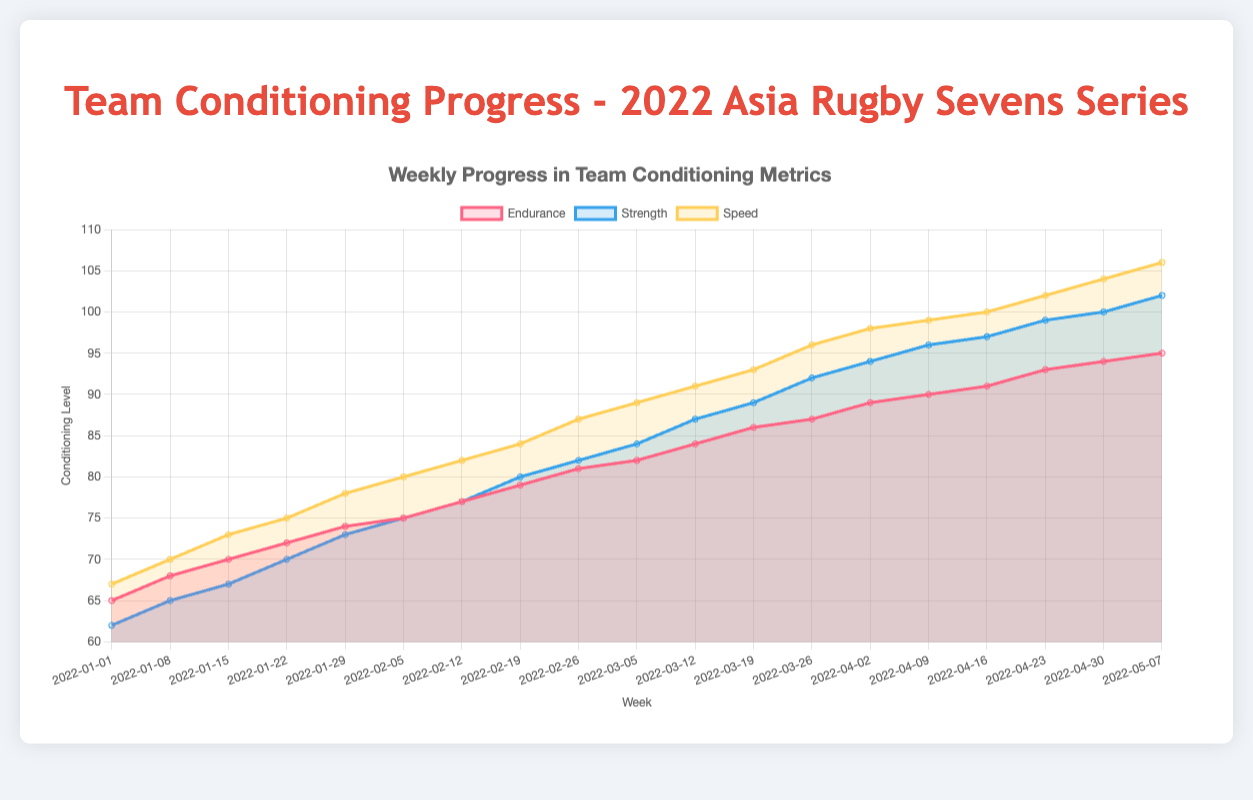What is the title of the chart? The title of the chart is usually displayed at the top and clearly indicates the purpose of the chart. In this case, at the top of the chart, it reads "Weekly Progress in Team Conditioning Metrics."
Answer: Weekly Progress in Team Conditioning Metrics What is the conditioning level of the team's endurance on the week of 2022-02-05? Find the data point corresponding to the week of 2022-02-05 on the x-axis, then look at the value indicated for endurance on the y-axis. The chart will show a filled area reaching the value.
Answer: 75 How many different metrics are visualized in this chart? Count the distinct datasets represented in the area chart, each with a different color and label. From the legend, we see three datasets: Endurance, Strength, and Speed.
Answer: 3 Which metric showed the highest level in the final week (2022-05-07)? Look at the data point for the final week (2022-05-07) and compare the values for endurance, strength, and speed. The highest value among them is the metric that showed the highest level.
Answer: Speed How did the strength metric progress from 2022-01-01 to 2022-05-07? Starting at 62 on 2022-01-01, strength steadily increases every week, reaching 102 on 2022-05-07.
Answer: It increased steadily from 62 to 102 Which metric increased the most from the first to the last recorded week? Starting values and ending values for each metric: Endurance (65 to 95), Strength (62 to 102), Speed (67 to 106). Calculate the difference for each: Endurance (95 - 65 = 30), Strength (102 - 62 = 40), Speed (106 - 67 = 39).
Answer: Strength What is the average speed metric over the first four weeks of 2022? Look at the speed values for the first four weeks: 67, 70, 73, 75. Sum these values (67 + 70 + 73 + 75 = 285) and divide by the number of weeks (285 / 4 = 71.25).
Answer: 71.25 Was there any week where the strength surpassed the endurance level? If so, which week(s)? Compare the weekly values of strength and endurance. Strength surpasses endurance in any week where the strength value is higher. From the data, this occurred from 2022-03-26 onwards.
Answer: 2022-03-26, 2022-04-02, 2022-04-09, 2022-04-16, 2022-04-23, 2022-04-30, 2022-05-07 How did the endurance and speed metrics compare on 2022-04-16? Find the values for endurance and speed on 2022-04-16. Endurance is 91, and speed is 100. Speed is higher than endurance on this date.
Answer: Speed was higher than endurance What pattern do you observe in the overall progress of the metrics leading up to the 2022 Asia Rugby Sevens Series? Observing the entire chart, all three metrics (endurance, strength, speed) show a consistent upward trend, indicating continuous improvement and conditioning of the team leading up to the series.
Answer: Continuous improvement 